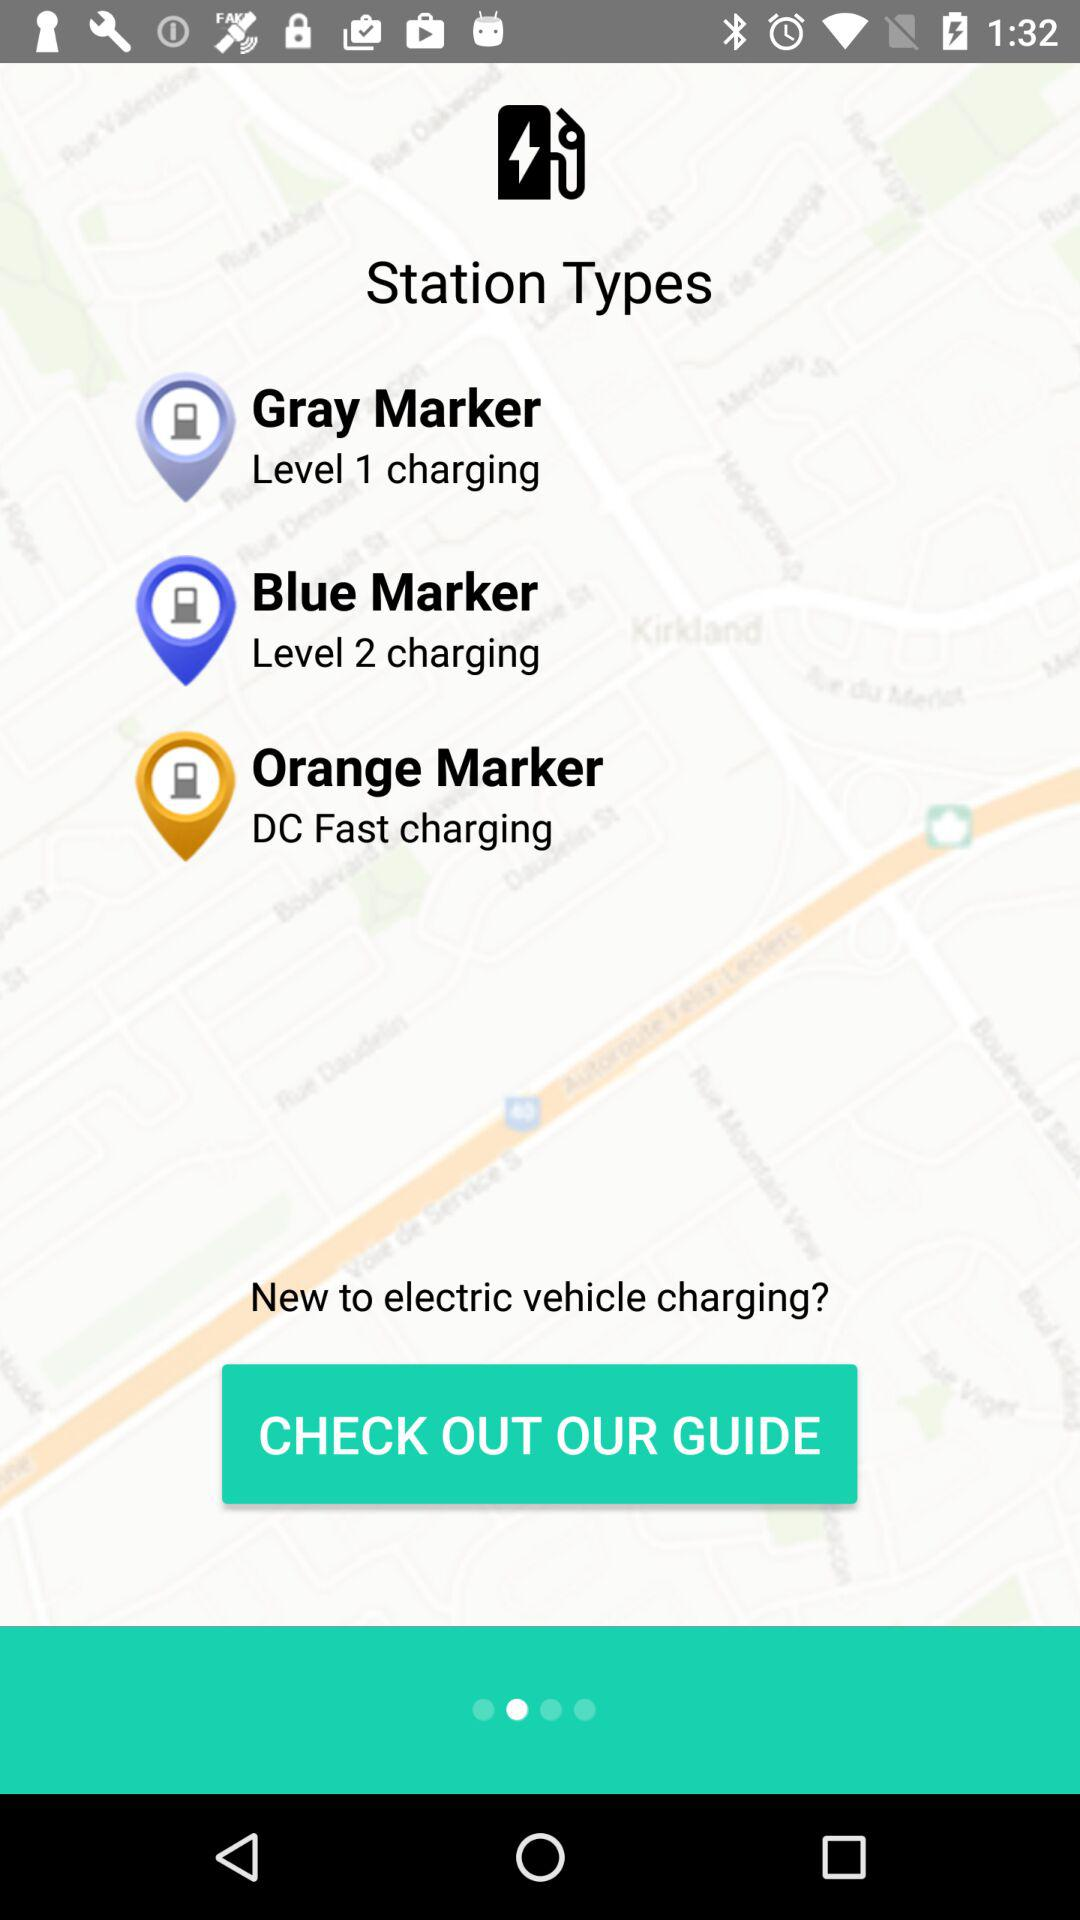How many charging stations have a marker that is not orange?
Answer the question using a single word or phrase. 2 